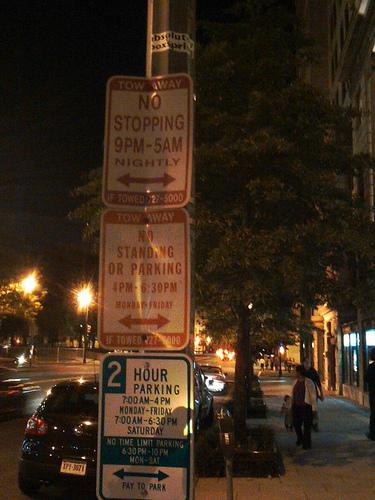Question: when was the picture taken?
Choices:
A. On holloween.
B. Nighttime.
C. At night.
D. Early morning.
Answer with the letter. Answer: C Question: what are the signs on?
Choices:
A. Windows.
B. Boards.
C. The pole.
D. Cars.
Answer with the letter. Answer: C Question: how many signs are there?
Choices:
A. One.
B. Three.
C. Two.
D. Four.
Answer with the letter. Answer: B Question: what color are the lights?
Choices:
A. Orange.
B. Red.
C. Yellow.
D. Green.
Answer with the letter. Answer: A Question: where was the picture taken?
Choices:
A. On a street corner.
B. On the road.
C. By the sign.
D. By the pole.
Answer with the letter. Answer: A 